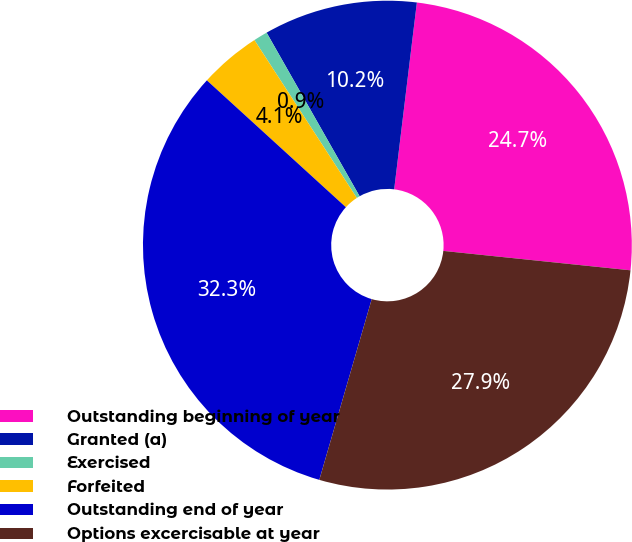<chart> <loc_0><loc_0><loc_500><loc_500><pie_chart><fcel>Outstanding beginning of year<fcel>Granted (a)<fcel>Exercised<fcel>Forfeited<fcel>Outstanding end of year<fcel>Options excercisable at year<nl><fcel>24.72%<fcel>10.15%<fcel>0.93%<fcel>4.07%<fcel>32.28%<fcel>27.85%<nl></chart> 